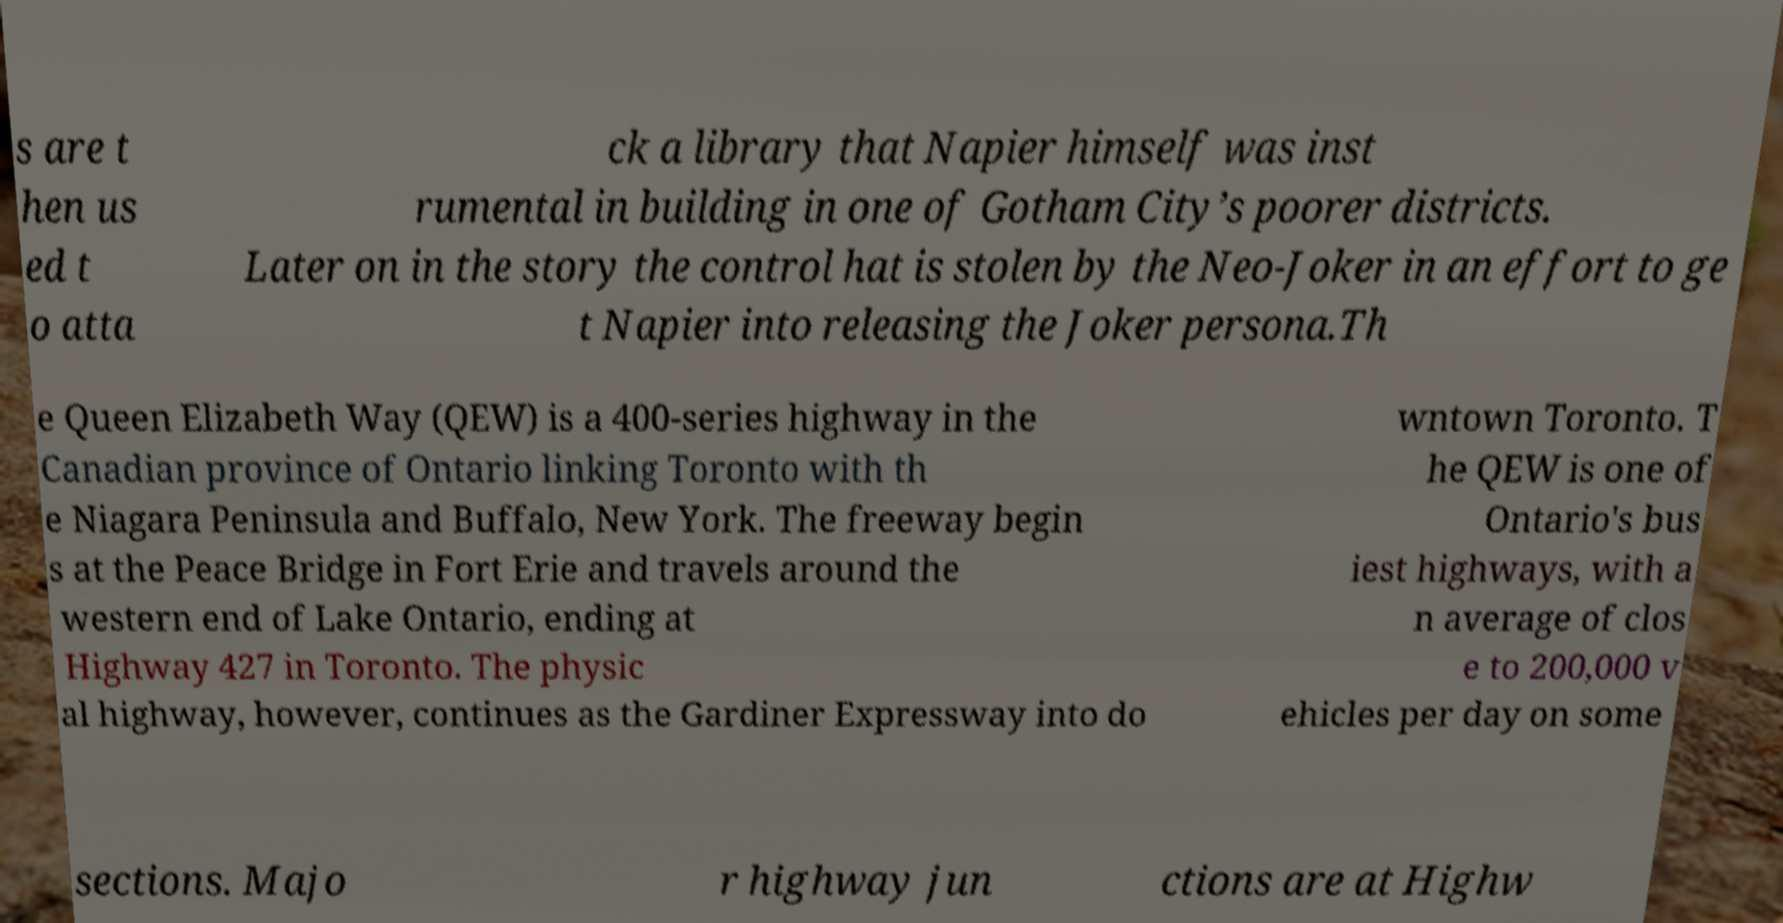Could you assist in decoding the text presented in this image and type it out clearly? s are t hen us ed t o atta ck a library that Napier himself was inst rumental in building in one of Gotham City’s poorer districts. Later on in the story the control hat is stolen by the Neo-Joker in an effort to ge t Napier into releasing the Joker persona.Th e Queen Elizabeth Way (QEW) is a 400-series highway in the Canadian province of Ontario linking Toronto with th e Niagara Peninsula and Buffalo, New York. The freeway begin s at the Peace Bridge in Fort Erie and travels around the western end of Lake Ontario, ending at Highway 427 in Toronto. The physic al highway, however, continues as the Gardiner Expressway into do wntown Toronto. T he QEW is one of Ontario's bus iest highways, with a n average of clos e to 200,000 v ehicles per day on some sections. Majo r highway jun ctions are at Highw 